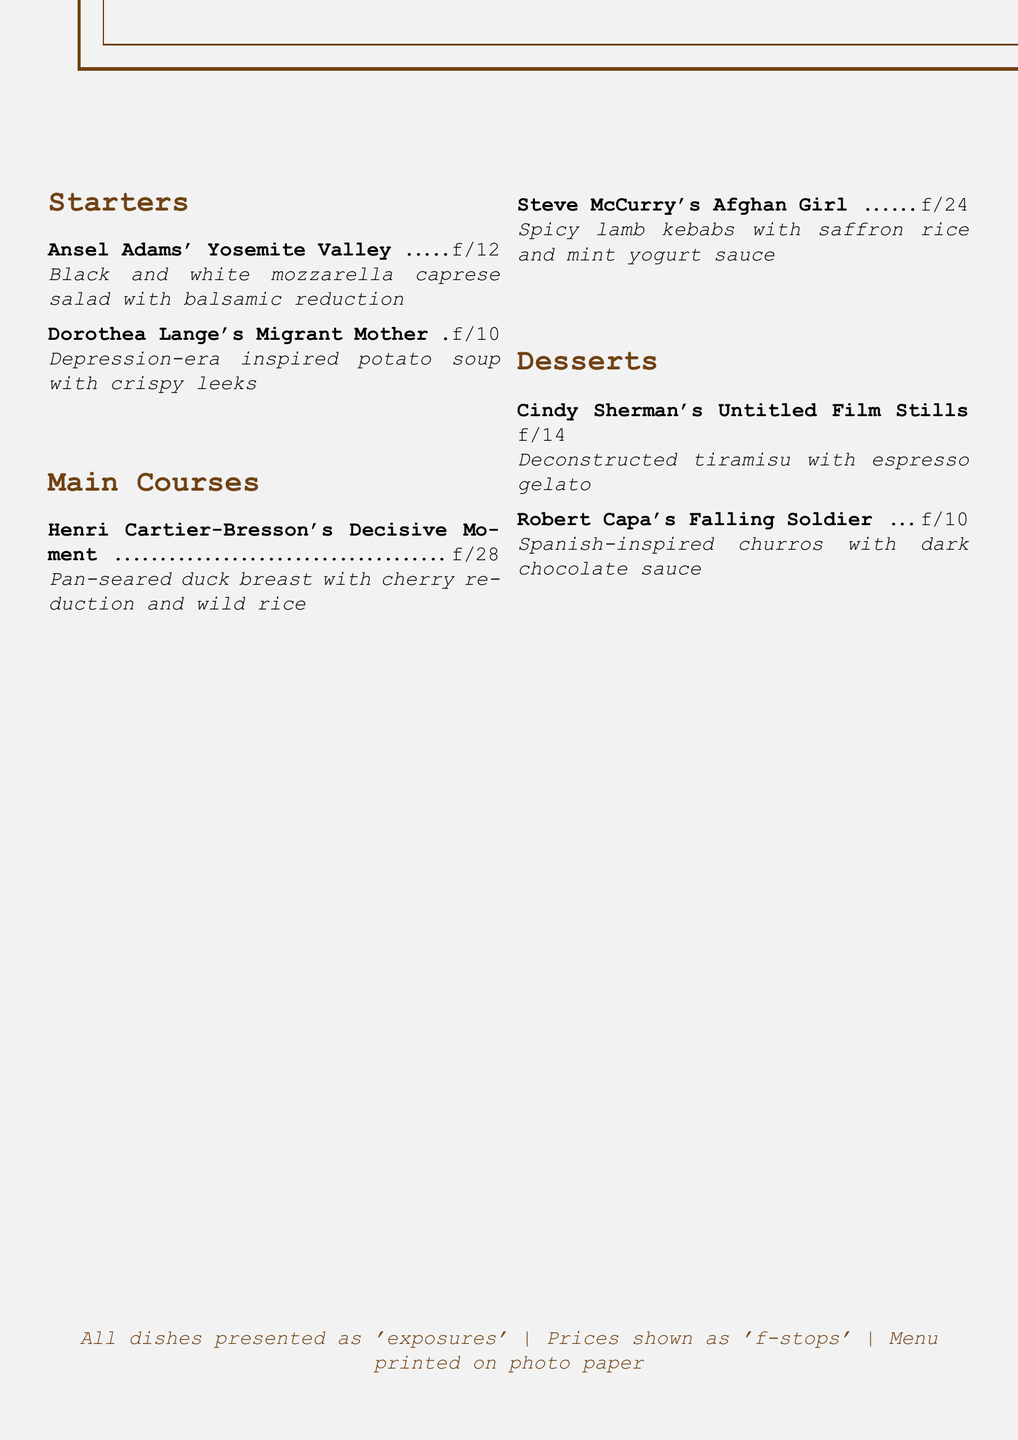What is the name of the restaurant? The name of the restaurant is presented at the top of the menu.
Answer: Aperture Eats Who is the photographer associated with the "Migrant Mother" dish? The dish "Migrant Mother" is named after a famous photographer known for documenting the Great Depression.
Answer: Dorothea Lange What is the price of the "Decisive Moment" main course? The price of the "Decisive Moment" dish is indicated next to its name in the menu.
Answer: 28 Which dessert is inspired by a film series? The dessert inspired by a series of photographs is noted for its unique style on the menu.
Answer: Cindy Sherman's Untitled Film Stills What type of soup is offered as a starter? The starter soup type is highlighted, revealing its historical inspiration within the menu context.
Answer: Potato soup What is the main ingredient in the dish named after "Afghan Girl"? The main ingredient of the dish corresponds to its cultural origin as described in the menu.
Answer: Lamb Which dish features churros? This dessert is mentioned, linking it to a notable photograph in the context of the menu.
Answer: Robert Capa's Falling Soldier How many starters are listed on the menu? The starters section contains a specific number of items that can be counted directly from the menu.
Answer: 2 What is the unique characteristic of the menu paper? The menu description specifies a particular type of material used for printing it, which is notable for its artistic theme.
Answer: Photo paper 